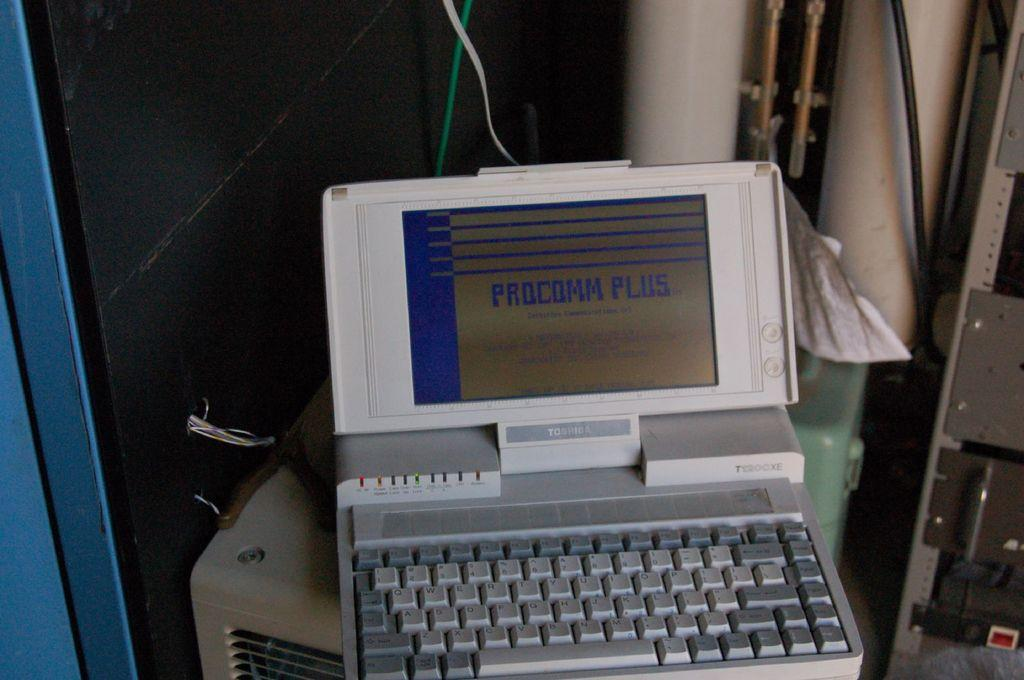<image>
Render a clear and concise summary of the photo. Procomm Plus written in blue on a computer 